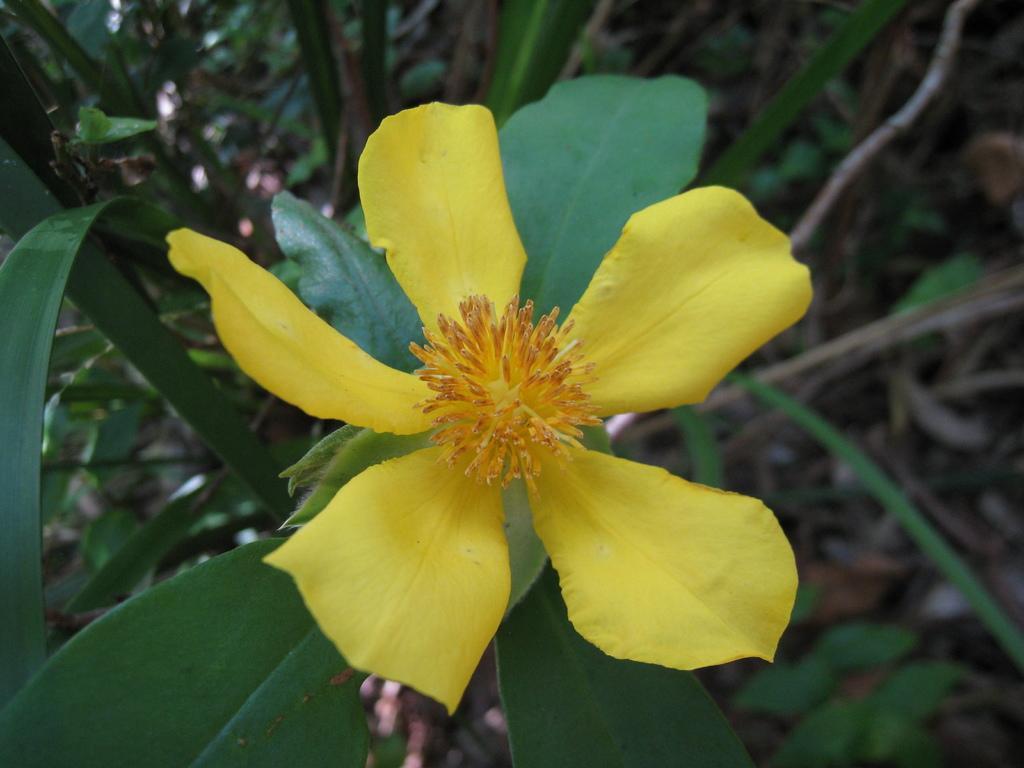Could you give a brief overview of what you see in this image? This picture is clicked outside. In the center we can see a yellow color flower and green color leaves of a plant. In the background we can see the dry stems and the plants and some other objects. 